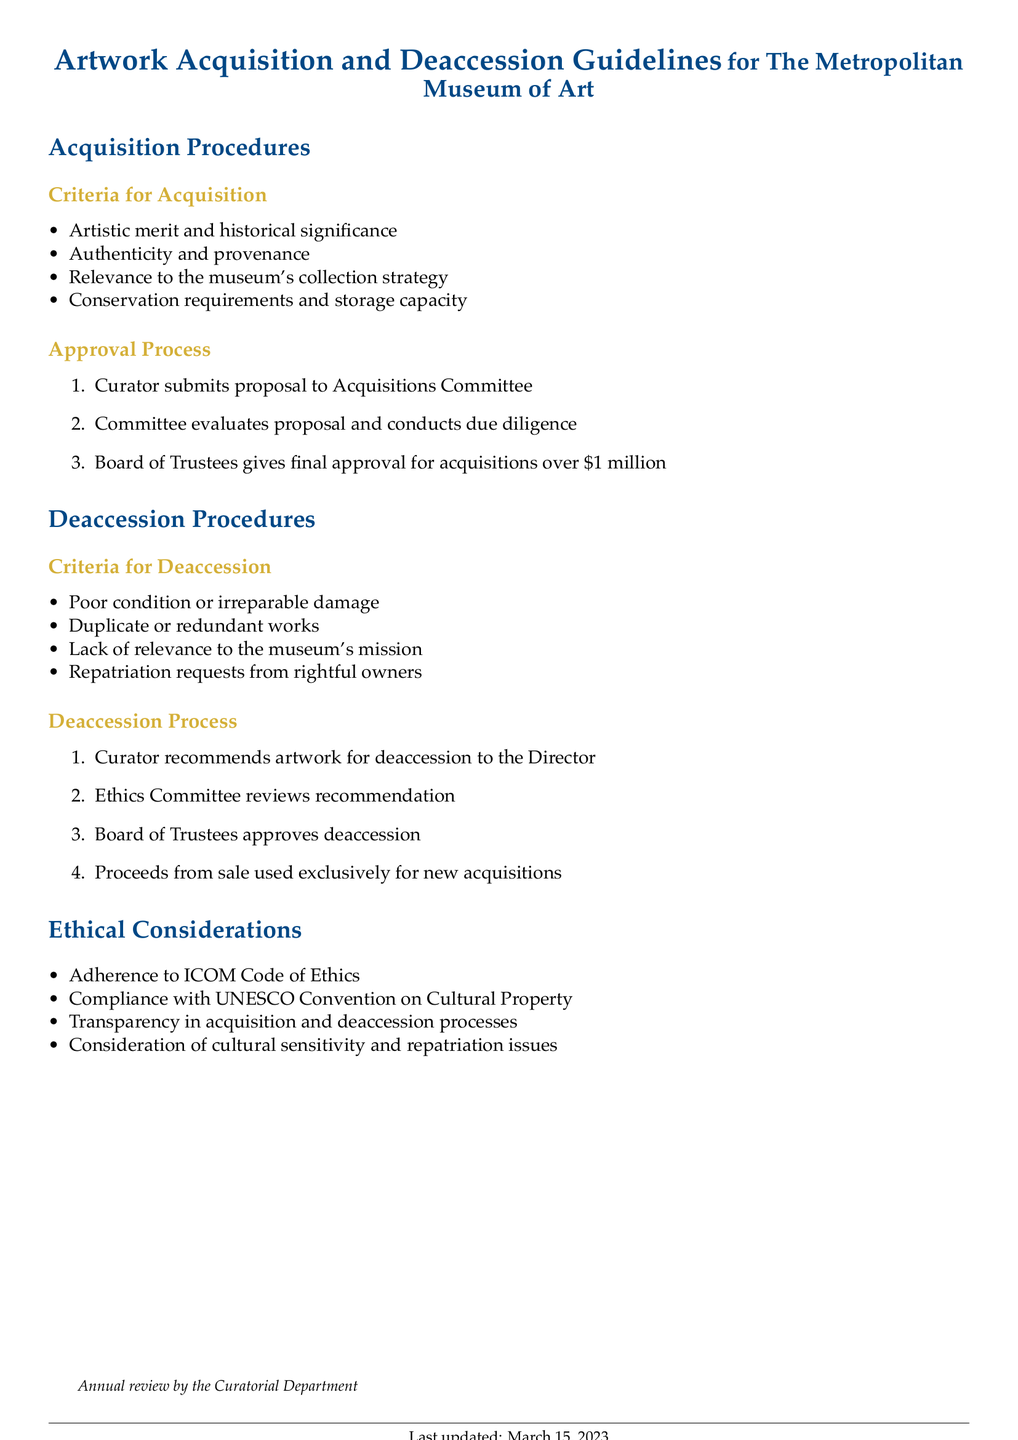What are the criteria for acquisition? The criteria for acquisition include artistic merit, historical significance, authenticity, provenance, relevance to the museum's collection strategy, conservation requirements, and storage capacity.
Answer: Artistic merit and historical significance, authenticity and provenance, relevance to the museum's collection strategy, conservation requirements and storage capacity Who approves acquisitions over one million dollars? The Board of Trustees is responsible for giving final approval for acquisitions that exceed one million dollars.
Answer: Board of Trustees What are the criteria for deaccession? The criteria for deaccession include poor condition or irreparable damage, duplicate or redundant works, lack of relevance to the museum's mission, and repatriation requests from rightful owners.
Answer: Poor condition or irreparable damage, duplicate or redundant works, lack of relevance to the museum's mission, repatriation requests from rightful owners Who reviews the recommendation for deaccession? The Ethics Committee is tasked with reviewing the curator's recommendation for deaccession.
Answer: Ethics Committee What is done with the proceeds from the sale after deaccession? The document states that proceeds from the sale of deaccessioned artworks are to be used exclusively for new acquisitions.
Answer: Used exclusively for new acquisitions What standard of ethics does the museum adhere to? The museum adheres to the ICOM Code of Ethics as stated in the document.
Answer: ICOM Code of Ethics How often is the document reviewed? The document undergoes an annual review by the Curatorial Department, as mentioned in the footnote.
Answer: Annual What aspect of the acquisition and deaccession processes is emphasized in terms of transparency? The document highlights transparency as a key aspect of the acquisition and deaccession processes.
Answer: Transparency in acquisition and deaccession processes What is a reason for deaccessioning an artwork? A lack of relevance to the museum's mission is one of the reasons for deaccessioning an artwork.
Answer: Lack of relevance to the museum's mission 